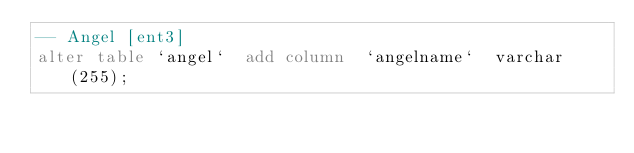<code> <loc_0><loc_0><loc_500><loc_500><_SQL_>-- Angel [ent3]
alter table `angel`  add column  `angelname`  varchar(255);


</code> 